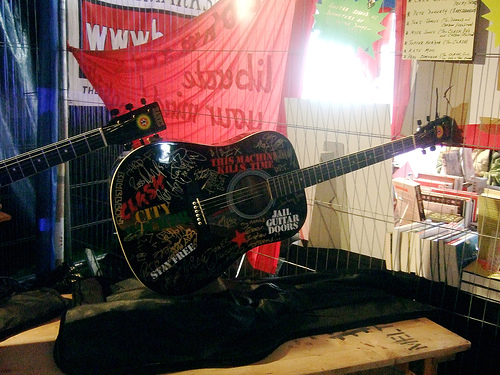<image>
Is the curtain on the guitar? No. The curtain is not positioned on the guitar. They may be near each other, but the curtain is not supported by or resting on top of the guitar. 